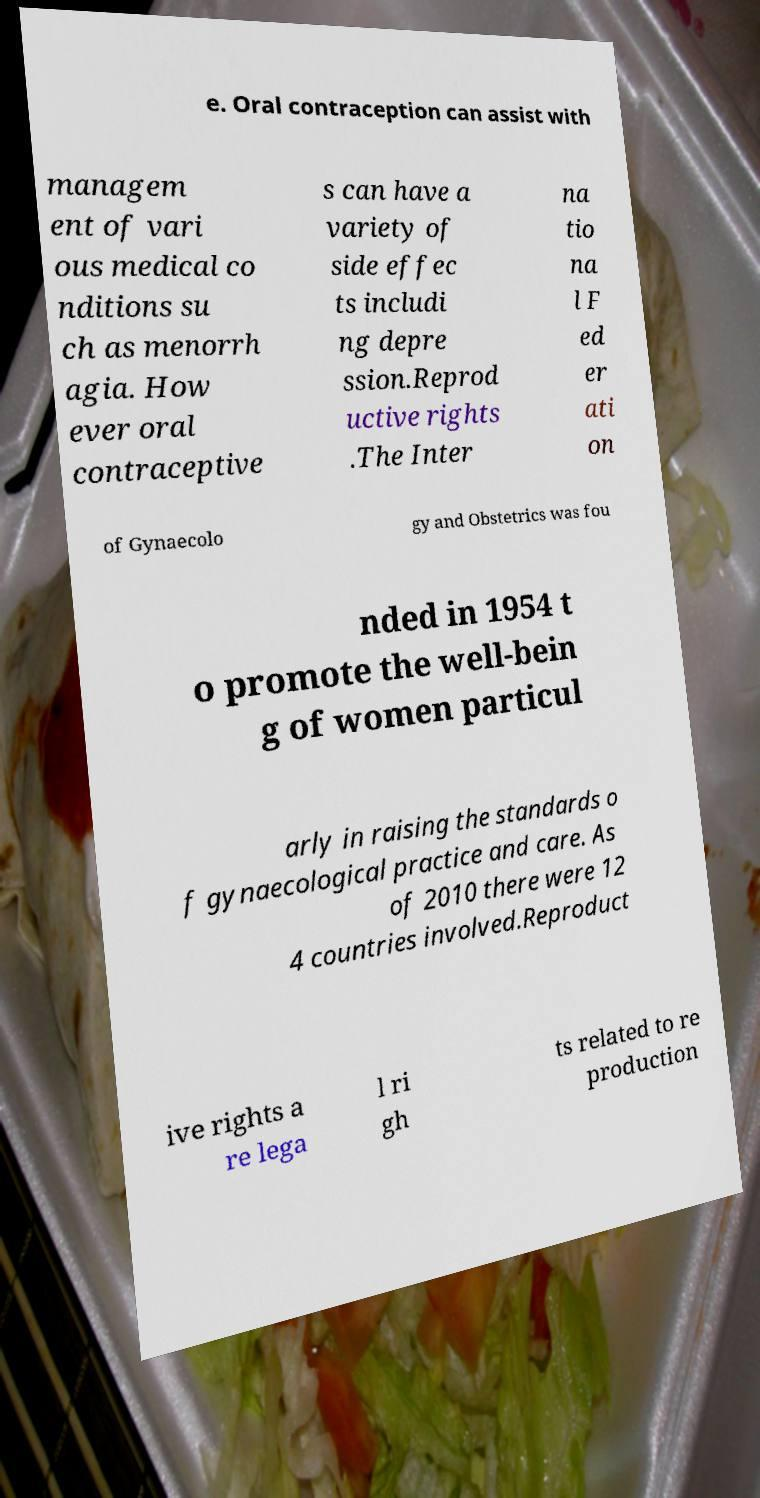I need the written content from this picture converted into text. Can you do that? e. Oral contraception can assist with managem ent of vari ous medical co nditions su ch as menorrh agia. How ever oral contraceptive s can have a variety of side effec ts includi ng depre ssion.Reprod uctive rights .The Inter na tio na l F ed er ati on of Gynaecolo gy and Obstetrics was fou nded in 1954 t o promote the well-bein g of women particul arly in raising the standards o f gynaecological practice and care. As of 2010 there were 12 4 countries involved.Reproduct ive rights a re lega l ri gh ts related to re production 